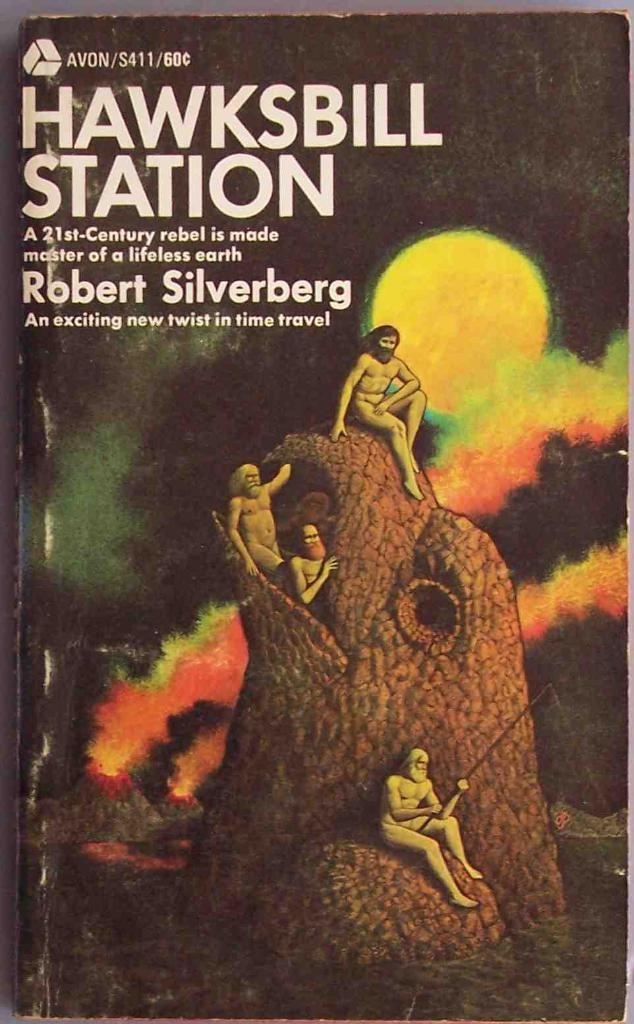<image>
Share a concise interpretation of the image provided. the cover of a book that says 'hawksbill station' at the top 